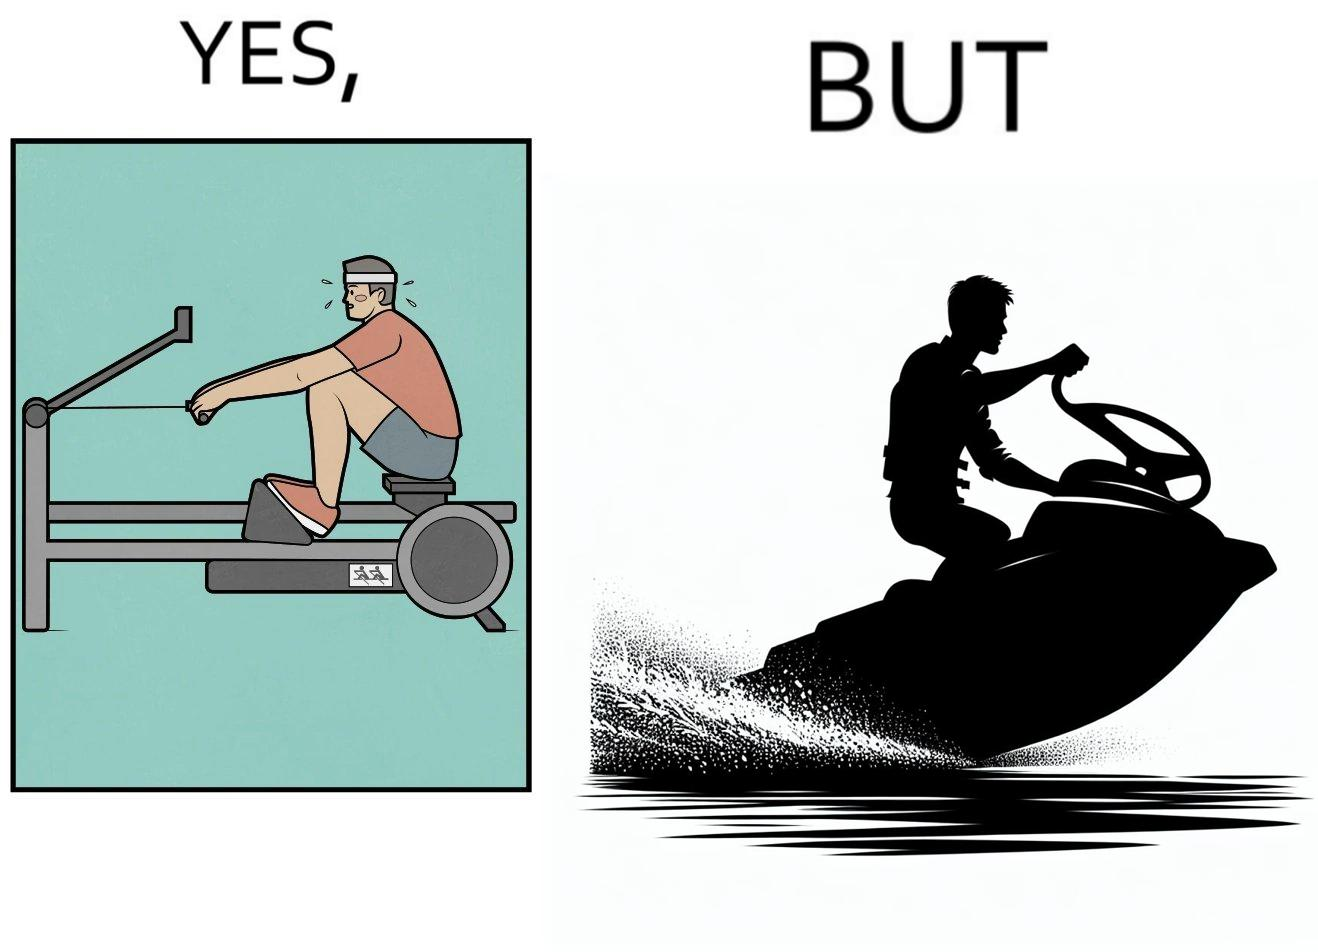Would you classify this image as satirical? Yes, this image is satirical. 